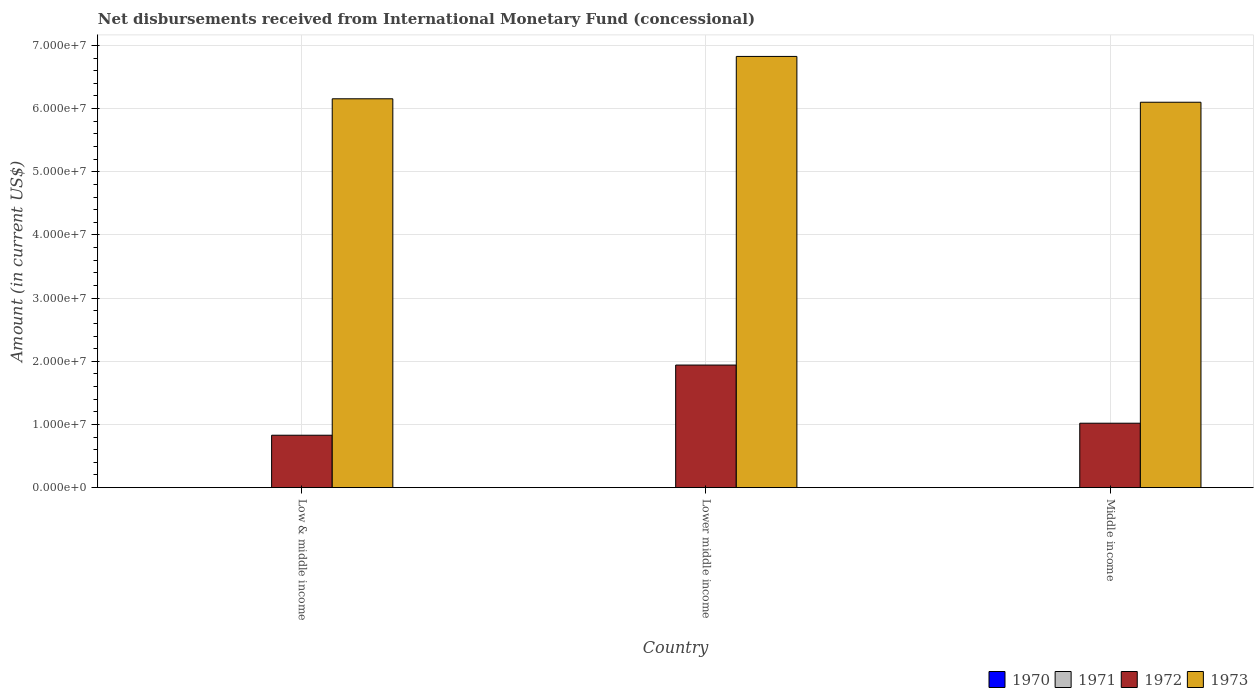How many groups of bars are there?
Your answer should be very brief. 3. Are the number of bars on each tick of the X-axis equal?
Your answer should be compact. Yes. How many bars are there on the 3rd tick from the left?
Offer a terse response. 2. How many bars are there on the 3rd tick from the right?
Your response must be concise. 2. What is the label of the 2nd group of bars from the left?
Make the answer very short. Lower middle income. What is the amount of disbursements received from International Monetary Fund in 1972 in Lower middle income?
Ensure brevity in your answer.  1.94e+07. Across all countries, what is the maximum amount of disbursements received from International Monetary Fund in 1973?
Your answer should be compact. 6.83e+07. In which country was the amount of disbursements received from International Monetary Fund in 1972 maximum?
Give a very brief answer. Lower middle income. What is the total amount of disbursements received from International Monetary Fund in 1971 in the graph?
Offer a very short reply. 0. What is the difference between the amount of disbursements received from International Monetary Fund in 1972 in Low & middle income and that in Middle income?
Your answer should be very brief. -1.90e+06. What is the difference between the amount of disbursements received from International Monetary Fund in 1973 in Low & middle income and the amount of disbursements received from International Monetary Fund in 1970 in Lower middle income?
Keep it short and to the point. 6.16e+07. What is the average amount of disbursements received from International Monetary Fund in 1973 per country?
Offer a terse response. 6.36e+07. What is the difference between the amount of disbursements received from International Monetary Fund of/in 1972 and amount of disbursements received from International Monetary Fund of/in 1973 in Middle income?
Ensure brevity in your answer.  -5.08e+07. What is the ratio of the amount of disbursements received from International Monetary Fund in 1972 in Low & middle income to that in Middle income?
Provide a short and direct response. 0.81. Is the difference between the amount of disbursements received from International Monetary Fund in 1972 in Low & middle income and Middle income greater than the difference between the amount of disbursements received from International Monetary Fund in 1973 in Low & middle income and Middle income?
Make the answer very short. No. What is the difference between the highest and the second highest amount of disbursements received from International Monetary Fund in 1973?
Keep it short and to the point. -7.25e+06. What is the difference between the highest and the lowest amount of disbursements received from International Monetary Fund in 1973?
Your answer should be very brief. 7.25e+06. In how many countries, is the amount of disbursements received from International Monetary Fund in 1970 greater than the average amount of disbursements received from International Monetary Fund in 1970 taken over all countries?
Keep it short and to the point. 0. Is the sum of the amount of disbursements received from International Monetary Fund in 1972 in Low & middle income and Lower middle income greater than the maximum amount of disbursements received from International Monetary Fund in 1970 across all countries?
Ensure brevity in your answer.  Yes. How many bars are there?
Provide a short and direct response. 6. Are all the bars in the graph horizontal?
Your answer should be compact. No. How many countries are there in the graph?
Offer a terse response. 3. What is the title of the graph?
Keep it short and to the point. Net disbursements received from International Monetary Fund (concessional). What is the label or title of the X-axis?
Keep it short and to the point. Country. What is the label or title of the Y-axis?
Offer a terse response. Amount (in current US$). What is the Amount (in current US$) in 1970 in Low & middle income?
Your response must be concise. 0. What is the Amount (in current US$) of 1972 in Low & middle income?
Offer a terse response. 8.30e+06. What is the Amount (in current US$) in 1973 in Low & middle income?
Your answer should be very brief. 6.16e+07. What is the Amount (in current US$) of 1971 in Lower middle income?
Offer a very short reply. 0. What is the Amount (in current US$) of 1972 in Lower middle income?
Give a very brief answer. 1.94e+07. What is the Amount (in current US$) in 1973 in Lower middle income?
Make the answer very short. 6.83e+07. What is the Amount (in current US$) of 1970 in Middle income?
Provide a short and direct response. 0. What is the Amount (in current US$) in 1972 in Middle income?
Your response must be concise. 1.02e+07. What is the Amount (in current US$) of 1973 in Middle income?
Your response must be concise. 6.10e+07. Across all countries, what is the maximum Amount (in current US$) in 1972?
Provide a short and direct response. 1.94e+07. Across all countries, what is the maximum Amount (in current US$) of 1973?
Make the answer very short. 6.83e+07. Across all countries, what is the minimum Amount (in current US$) in 1972?
Your answer should be very brief. 8.30e+06. Across all countries, what is the minimum Amount (in current US$) in 1973?
Offer a very short reply. 6.10e+07. What is the total Amount (in current US$) in 1971 in the graph?
Keep it short and to the point. 0. What is the total Amount (in current US$) of 1972 in the graph?
Make the answer very short. 3.79e+07. What is the total Amount (in current US$) of 1973 in the graph?
Provide a succinct answer. 1.91e+08. What is the difference between the Amount (in current US$) in 1972 in Low & middle income and that in Lower middle income?
Give a very brief answer. -1.11e+07. What is the difference between the Amount (in current US$) in 1973 in Low & middle income and that in Lower middle income?
Your answer should be compact. -6.70e+06. What is the difference between the Amount (in current US$) in 1972 in Low & middle income and that in Middle income?
Ensure brevity in your answer.  -1.90e+06. What is the difference between the Amount (in current US$) of 1973 in Low & middle income and that in Middle income?
Your response must be concise. 5.46e+05. What is the difference between the Amount (in current US$) of 1972 in Lower middle income and that in Middle income?
Offer a terse response. 9.21e+06. What is the difference between the Amount (in current US$) of 1973 in Lower middle income and that in Middle income?
Give a very brief answer. 7.25e+06. What is the difference between the Amount (in current US$) of 1972 in Low & middle income and the Amount (in current US$) of 1973 in Lower middle income?
Your response must be concise. -6.00e+07. What is the difference between the Amount (in current US$) of 1972 in Low & middle income and the Amount (in current US$) of 1973 in Middle income?
Provide a succinct answer. -5.27e+07. What is the difference between the Amount (in current US$) in 1972 in Lower middle income and the Amount (in current US$) in 1973 in Middle income?
Give a very brief answer. -4.16e+07. What is the average Amount (in current US$) in 1970 per country?
Your answer should be compact. 0. What is the average Amount (in current US$) of 1971 per country?
Provide a succinct answer. 0. What is the average Amount (in current US$) in 1972 per country?
Make the answer very short. 1.26e+07. What is the average Amount (in current US$) of 1973 per country?
Make the answer very short. 6.36e+07. What is the difference between the Amount (in current US$) in 1972 and Amount (in current US$) in 1973 in Low & middle income?
Your response must be concise. -5.33e+07. What is the difference between the Amount (in current US$) in 1972 and Amount (in current US$) in 1973 in Lower middle income?
Make the answer very short. -4.89e+07. What is the difference between the Amount (in current US$) in 1972 and Amount (in current US$) in 1973 in Middle income?
Give a very brief answer. -5.08e+07. What is the ratio of the Amount (in current US$) in 1972 in Low & middle income to that in Lower middle income?
Offer a very short reply. 0.43. What is the ratio of the Amount (in current US$) of 1973 in Low & middle income to that in Lower middle income?
Your response must be concise. 0.9. What is the ratio of the Amount (in current US$) of 1972 in Low & middle income to that in Middle income?
Your response must be concise. 0.81. What is the ratio of the Amount (in current US$) of 1972 in Lower middle income to that in Middle income?
Make the answer very short. 1.9. What is the ratio of the Amount (in current US$) of 1973 in Lower middle income to that in Middle income?
Make the answer very short. 1.12. What is the difference between the highest and the second highest Amount (in current US$) in 1972?
Keep it short and to the point. 9.21e+06. What is the difference between the highest and the second highest Amount (in current US$) of 1973?
Offer a very short reply. 6.70e+06. What is the difference between the highest and the lowest Amount (in current US$) of 1972?
Make the answer very short. 1.11e+07. What is the difference between the highest and the lowest Amount (in current US$) in 1973?
Make the answer very short. 7.25e+06. 